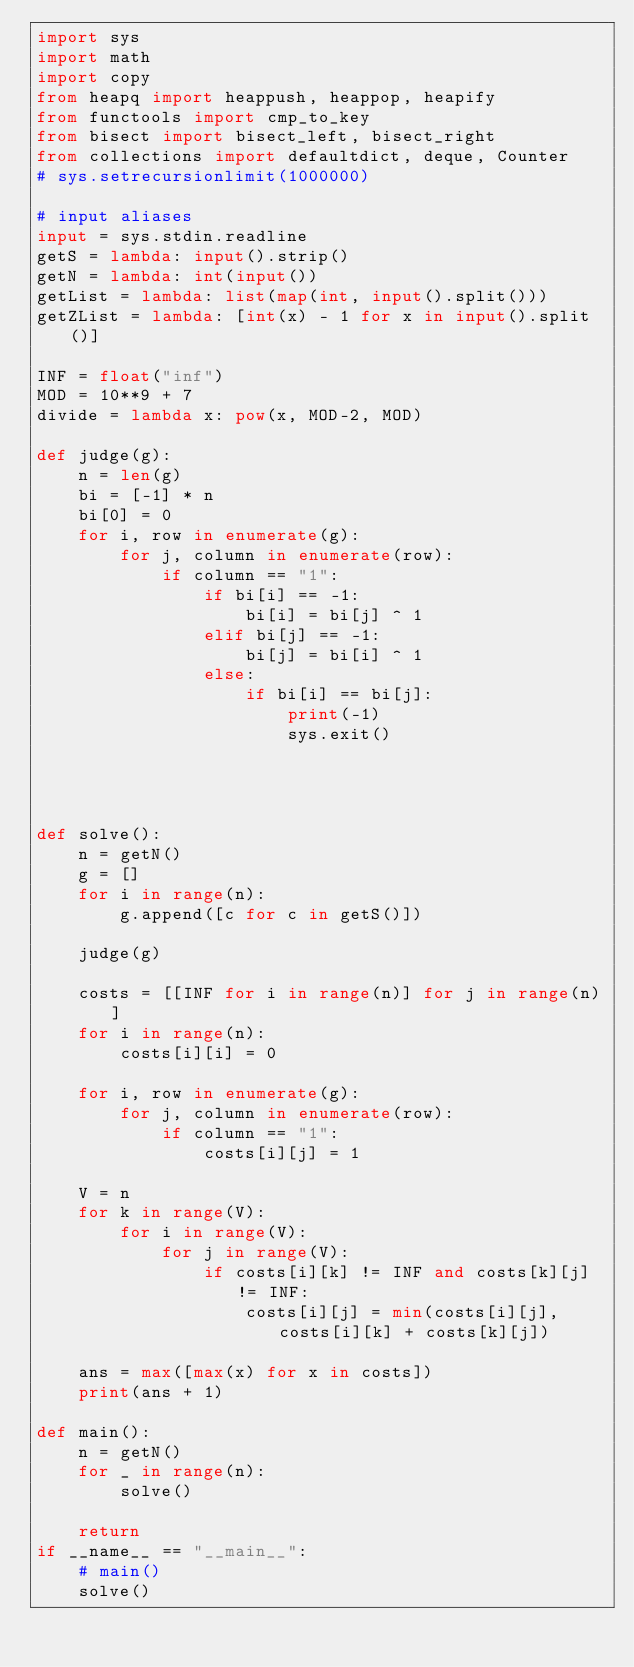<code> <loc_0><loc_0><loc_500><loc_500><_Python_>import sys
import math
import copy
from heapq import heappush, heappop, heapify
from functools import cmp_to_key
from bisect import bisect_left, bisect_right
from collections import defaultdict, deque, Counter
# sys.setrecursionlimit(1000000)

# input aliases
input = sys.stdin.readline
getS = lambda: input().strip()
getN = lambda: int(input())
getList = lambda: list(map(int, input().split()))
getZList = lambda: [int(x) - 1 for x in input().split()]

INF = float("inf")
MOD = 10**9 + 7
divide = lambda x: pow(x, MOD-2, MOD)

def judge(g):
    n = len(g)
    bi = [-1] * n
    bi[0] = 0
    for i, row in enumerate(g):
        for j, column in enumerate(row):
            if column == "1":
                if bi[i] == -1:
                    bi[i] = bi[j] ^ 1
                elif bi[j] == -1:
                    bi[j] = bi[i] ^ 1
                else:
                    if bi[i] == bi[j]:
                        print(-1)
                        sys.exit()




def solve():
    n = getN()
    g = []
    for i in range(n):
        g.append([c for c in getS()])

    judge(g)

    costs = [[INF for i in range(n)] for j in range(n)]
    for i in range(n):
        costs[i][i] = 0

    for i, row in enumerate(g):
        for j, column in enumerate(row):
            if column == "1":
                costs[i][j] = 1

    V = n
    for k in range(V):
        for i in range(V):
            for j in range(V):
                if costs[i][k] != INF and costs[k][j] != INF:
                    costs[i][j] = min(costs[i][j], costs[i][k] + costs[k][j])

    ans = max([max(x) for x in costs])
    print(ans + 1)

def main():
    n = getN()
    for _ in range(n):
        solve()

    return
if __name__ == "__main__":
    # main()
    solve()</code> 